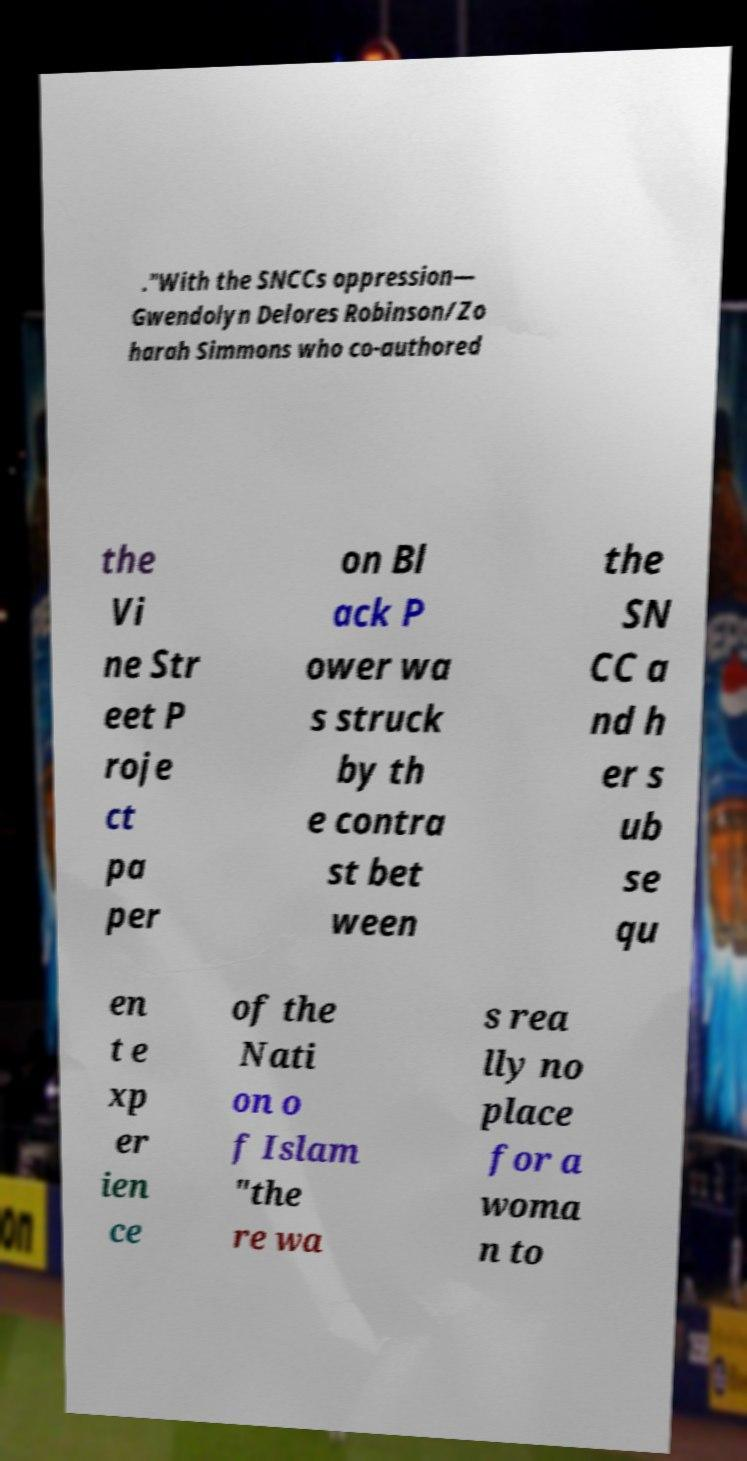There's text embedded in this image that I need extracted. Can you transcribe it verbatim? ."With the SNCCs oppression— Gwendolyn Delores Robinson/Zo harah Simmons who co-authored the Vi ne Str eet P roje ct pa per on Bl ack P ower wa s struck by th e contra st bet ween the SN CC a nd h er s ub se qu en t e xp er ien ce of the Nati on o f Islam "the re wa s rea lly no place for a woma n to 